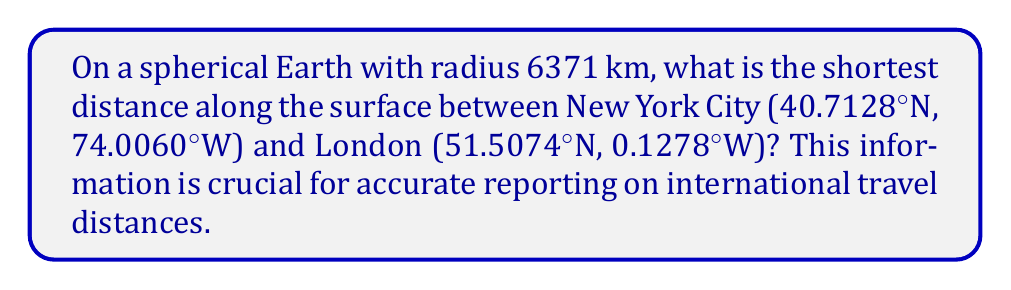Could you help me with this problem? To find the shortest distance between two points on a sphere, we need to use the great circle distance formula. Here are the steps:

1. Convert the latitudes and longitudes to radians:
   $\phi_1 = 40.7128° \times \frac{\pi}{180} = 0.7104$ rad
   $\lambda_1 = -74.0060° \times \frac{\pi}{180} = -1.2917$ rad
   $\phi_2 = 51.5074° \times \frac{\pi}{180} = 0.8990$ rad
   $\lambda_2 = -0.1278° \times \frac{\pi}{180} = -0.0022$ rad

2. Calculate the central angle $\Delta\sigma$ using the Haversine formula:
   $$\Delta\sigma = 2 \arcsin\left(\sqrt{\sin^2\left(\frac{\phi_2-\phi_1}{2}\right) + \cos\phi_1\cos\phi_2\sin^2\left(\frac{\lambda_2-\lambda_1}{2}\right)}\right)$$

3. Substitute the values:
   $$\Delta\sigma = 2 \arcsin\left(\sqrt{\sin^2\left(\frac{0.8990-0.7104}{2}\right) + \cos(0.7104)\cos(0.8990)\sin^2\left(\frac{-0.0022-(-1.2917)}{2}\right)}\right)$$

4. Evaluate:
   $\Delta\sigma \approx 0.9877$ rad

5. Calculate the distance $d$ using the sphere's radius $R$:
   $d = R \times \Delta\sigma$
   $d = 6371 \text{ km} \times 0.9877 \text{ rad}$
   $d \approx 6292.36 \text{ km}$
Answer: 6292.36 km 